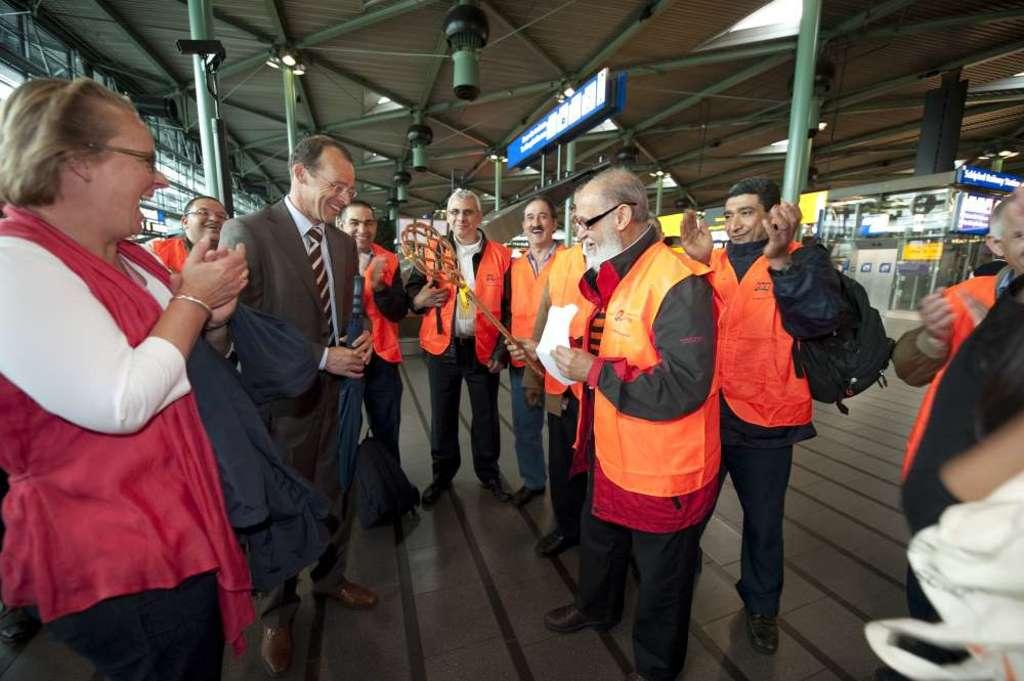How many people are in the image? There are people in the image, but the exact number is not specified. What are some of the people wearing? Some people are wearing the same uniform in the image. What can be seen illuminated in the image? There are lights in the image, which may indicate that certain areas or objects are illuminated. What structures are present in the image? There are poles and boards in the image. What type of writing can be seen on the box in the image? There is no box present in the image, so it is not possible to determine if there is any writing on it. 